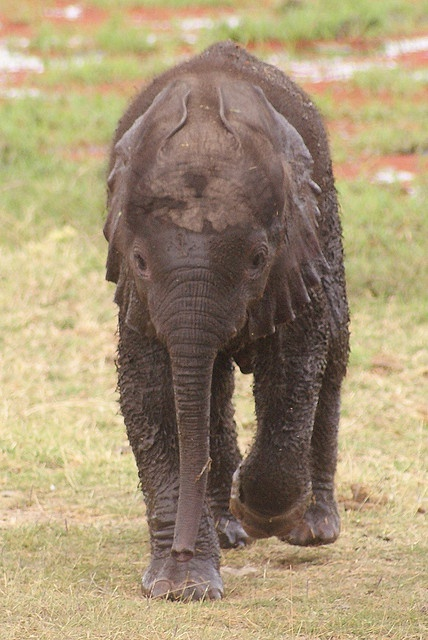Describe the objects in this image and their specific colors. I can see a elephant in tan, gray, and black tones in this image. 